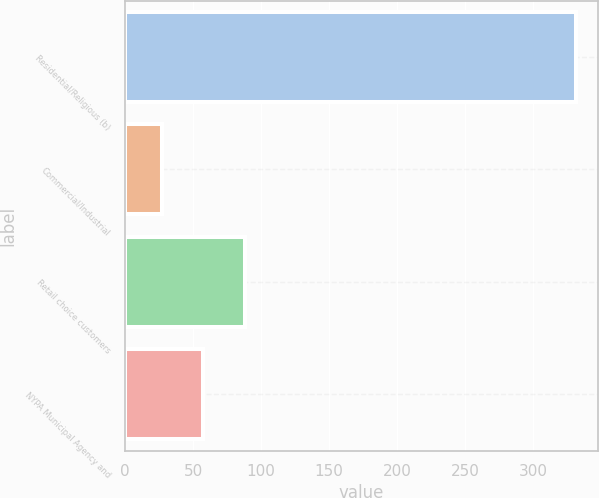Convert chart. <chart><loc_0><loc_0><loc_500><loc_500><bar_chart><fcel>Residential/Religious (b)<fcel>Commercial/Industrial<fcel>Retail choice customers<fcel>NYPA Municipal Agency and<nl><fcel>331<fcel>27<fcel>88<fcel>57.4<nl></chart> 